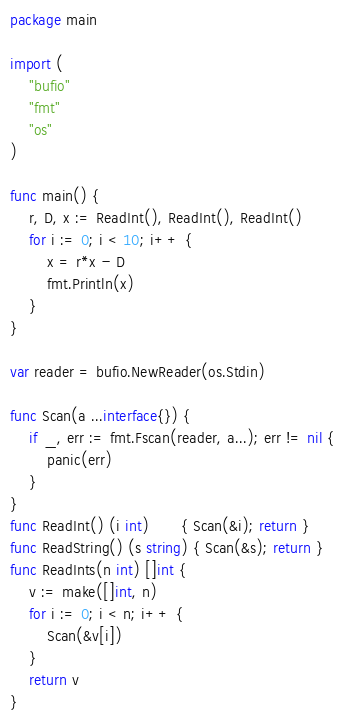Convert code to text. <code><loc_0><loc_0><loc_500><loc_500><_Go_>package main

import (
	"bufio"
	"fmt"
	"os"
)

func main() {
	r, D, x := ReadInt(), ReadInt(), ReadInt()
	for i := 0; i < 10; i++ {
		x = r*x - D
		fmt.Println(x)
	}
}

var reader = bufio.NewReader(os.Stdin)

func Scan(a ...interface{}) {
	if _, err := fmt.Fscan(reader, a...); err != nil {
		panic(err)
	}
}
func ReadInt() (i int)       { Scan(&i); return }
func ReadString() (s string) { Scan(&s); return }
func ReadInts(n int) []int {
	v := make([]int, n)
	for i := 0; i < n; i++ {
		Scan(&v[i])
	}
	return v
}
</code> 